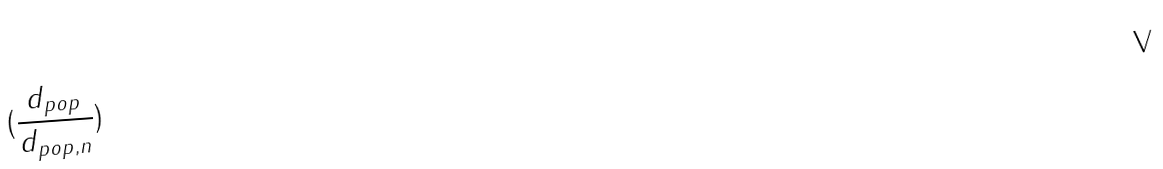<formula> <loc_0><loc_0><loc_500><loc_500>( \frac { d _ { p o p } } { d _ { p o p , n } } )</formula> 